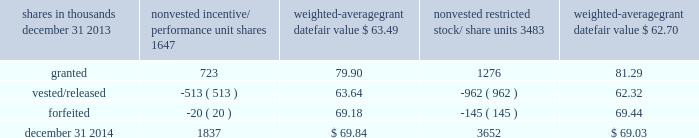To determine stock-based compensation expense , the grant date fair value is applied to the options granted with a reduction for estimated forfeitures .
We recognize compensation expense for stock options on a straight-line basis over the specified vesting period .
At december 31 , 2013 and 2012 , options for 10204000 and 12759000 shares of common stock were exercisable at a weighted-average price of $ 89.46 and $ 90.86 , respectively .
The total intrinsic value of options exercised during 2014 , 2013 and 2012 was $ 90 million , $ 86 million and $ 37 million , respectively .
Cash received from option exercises under all incentive plans for 2014 , 2013 and 2012 was approximately $ 215 million , $ 208 million and $ 118 million , respectively .
The tax benefit realized from option exercises under all incentive plans for 2014 , 2013 and 2012 was approximately $ 33 million , $ 31 million and $ 14 million , respectively .
Shares of common stock available during the next year for the granting of options and other awards under the incentive plans were 17997353 at december 31 , 2014 .
Total shares of pnc common stock authorized for future issuance under equity compensation plans totaled 19017057 shares at december 31 , 2014 , which includes shares available for issuance under the incentive plans and the employee stock purchase plan ( espp ) as described below .
During 2014 , we issued approximately 2.4 million shares from treasury stock in connection with stock option exercise activity .
As with past exercise activity , we currently intend to utilize primarily treasury stock for any future stock option exercises .
Awards granted to non-employee directors in 2014 , 2013 and 2012 include 21490 , 27076 and 25620 deferred stock units , respectively , awarded under the outside directors deferred stock unit plan .
A deferred stock unit is a phantom share of our common stock , which is accounted for as a liability until such awards are paid to the participants in cash .
As there are no vesting or service requirements on these awards , total compensation expense is recognized in full for these awards on the date of grant .
Incentive/performance unit share awards and restricted stock/share unit awards the fair value of nonvested incentive/performance unit share awards and restricted stock/share unit awards is initially determined based on prices not less than the market value of our common stock on the date of grant .
The value of certain incentive/performance unit share awards is subsequently remeasured based on the achievement of one or more financial and other performance goals .
The personnel and compensation committee ( 201cp&cc 201d ) of the board of directors approves the final award payout with respect to certain incentive/performance unit share awards .
These awards have either a three-year or a four-year performance period and are payable in either stock or a combination of stock and cash .
Restricted stock/share unit awards have various vesting periods generally ranging from 3 years to 5 years .
Beginning in 2013 , we incorporated several enhanced risk- related performance changes to certain long-term incentive compensation programs .
In addition to achieving certain financial performance metrics on both an absolute basis and relative to our peers , final payout amounts will be subject to reduction if pnc fails to meet certain risk-related performance metrics as specified in the award agreements .
However , the p&cc has the discretion to waive any or all of this reduction under certain circumstances .
The weighted-average grant date fair value of incentive/ performance unit share awards and restricted stock/unit awards granted in 2014 , 2013 and 2012 was $ 80.79 , $ 64.77 and $ 60.68 per share , respectively .
The total fair value of incentive/performance unit share and restricted stock/unit awards vested during 2014 , 2013 and 2012 was approximately $ 119 million , $ 63 million and $ 55 million , respectively .
We recognize compensation expense for such awards ratably over the corresponding vesting and/or performance periods for each type of program .
Table 121 : nonvested incentive/performance unit share awards and restricted stock/share unit awards 2013 rollforward shares in thousands nonvested incentive/ performance unit shares weighted- average grant date fair value nonvested restricted stock/ weighted- average grant date fair value .
The pnc financial services group , inc .
2013 form 10-k 185 .
In thousands , how much more value was there for nonvested incentive shares on dec 31 , 2014 than dec 31 , 2013? 
Computations: ((1837 * 69.84) - (1647 * 63.49))
Answer: 23728.05. 